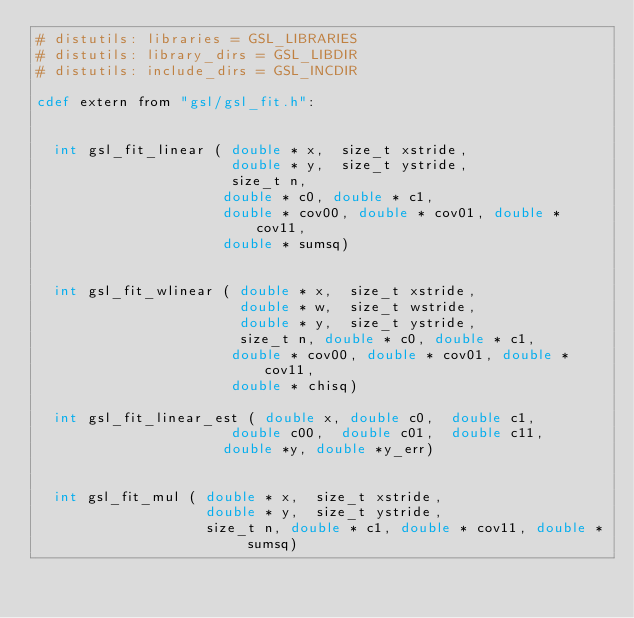<code> <loc_0><loc_0><loc_500><loc_500><_Cython_># distutils: libraries = GSL_LIBRARIES
# distutils: library_dirs = GSL_LIBDIR
# distutils: include_dirs = GSL_INCDIR

cdef extern from "gsl/gsl_fit.h":


  int gsl_fit_linear ( double * x,  size_t xstride,
                       double * y,  size_t ystride,
                       size_t n,
                      double * c0, double * c1,
                      double * cov00, double * cov01, double * cov11,
                      double * sumsq)


  int gsl_fit_wlinear ( double * x,  size_t xstride,
                        double * w,  size_t wstride,
                        double * y,  size_t ystride,
                        size_t n, double * c0, double * c1,
                       double * cov00, double * cov01, double * cov11,
                       double * chisq)

  int gsl_fit_linear_est ( double x, double c0,  double c1,
                       double c00,  double c01,  double c11,
                      double *y, double *y_err)


  int gsl_fit_mul ( double * x,  size_t xstride,
                    double * y,  size_t ystride,
                    size_t n, double * c1, double * cov11, double * sumsq)
</code> 